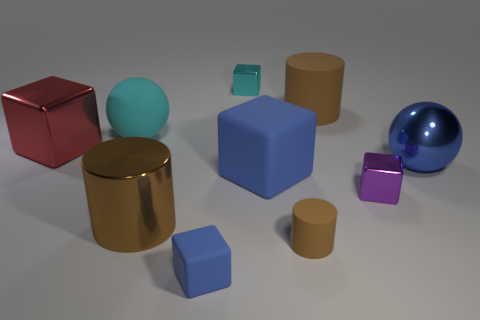How many other objects are the same shape as the small purple thing?
Offer a very short reply. 4. Does the red block have the same size as the brown matte cylinder that is in front of the large red thing?
Your response must be concise. No. What number of objects are either tiny red matte spheres or purple shiny objects?
Make the answer very short. 1. What number of other things are there of the same size as the cyan cube?
Give a very brief answer. 3. Does the tiny cylinder have the same color as the large metal object in front of the purple object?
Your answer should be compact. Yes. What number of cylinders are large blue shiny things or rubber things?
Ensure brevity in your answer.  2. Are there any other things that are the same color as the big metallic cylinder?
Ensure brevity in your answer.  Yes. There is a sphere on the left side of the large ball that is on the right side of the tiny blue thing; what is its material?
Offer a very short reply. Rubber. Do the purple cube and the big brown cylinder in front of the large red shiny object have the same material?
Ensure brevity in your answer.  Yes. How many things are blue cubes in front of the tiny purple metal thing or big balls?
Offer a very short reply. 3. 